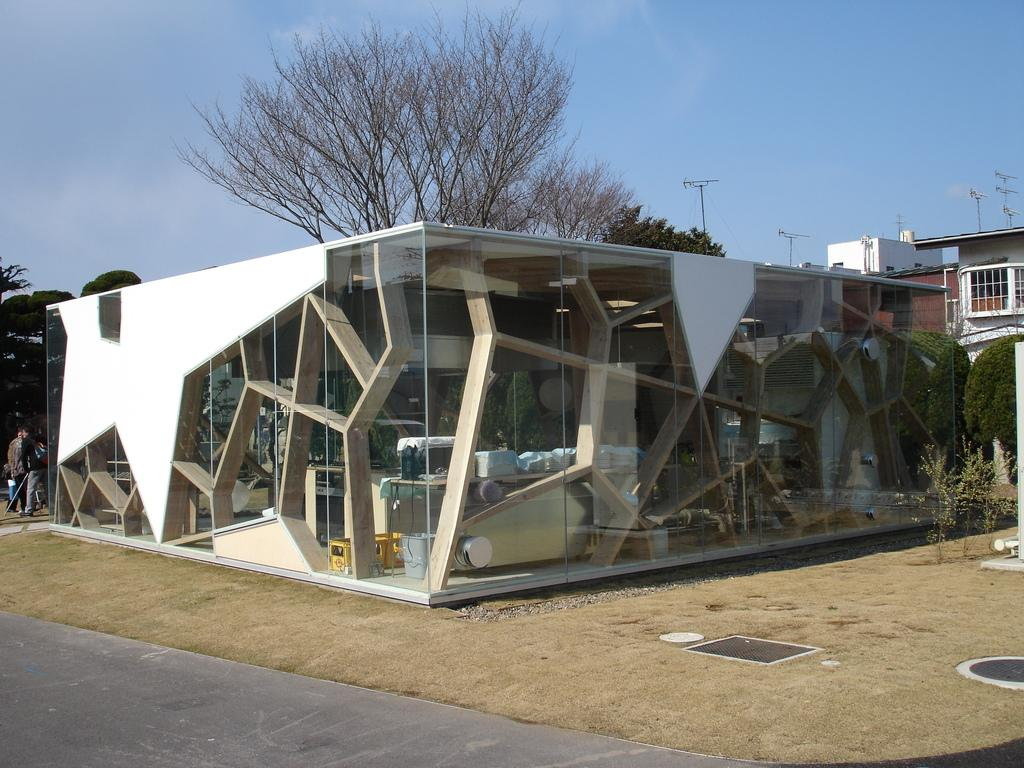What type of surface can be seen in the image? There is a road in the image. What type of vegetation is present in the image? There is a lawn, shrubs, and trees in the image. What type of structure is visible in the image? There is a glass building in the image. Are there any people in the image? Yes, there are people standing in the image. What else can be seen in the image? There are poles in the image. What is visible in the background of the image? The sky is visible in the background of the image, and there are clouds in the sky. What type of music can be heard coming from the glass building in the image? There is no indication of music or any sounds coming from the glass building in the image. What type of nut is being used to hold the poles together in the image? There is no mention of nuts or any fasteners being used to hold the poles together in the image. 